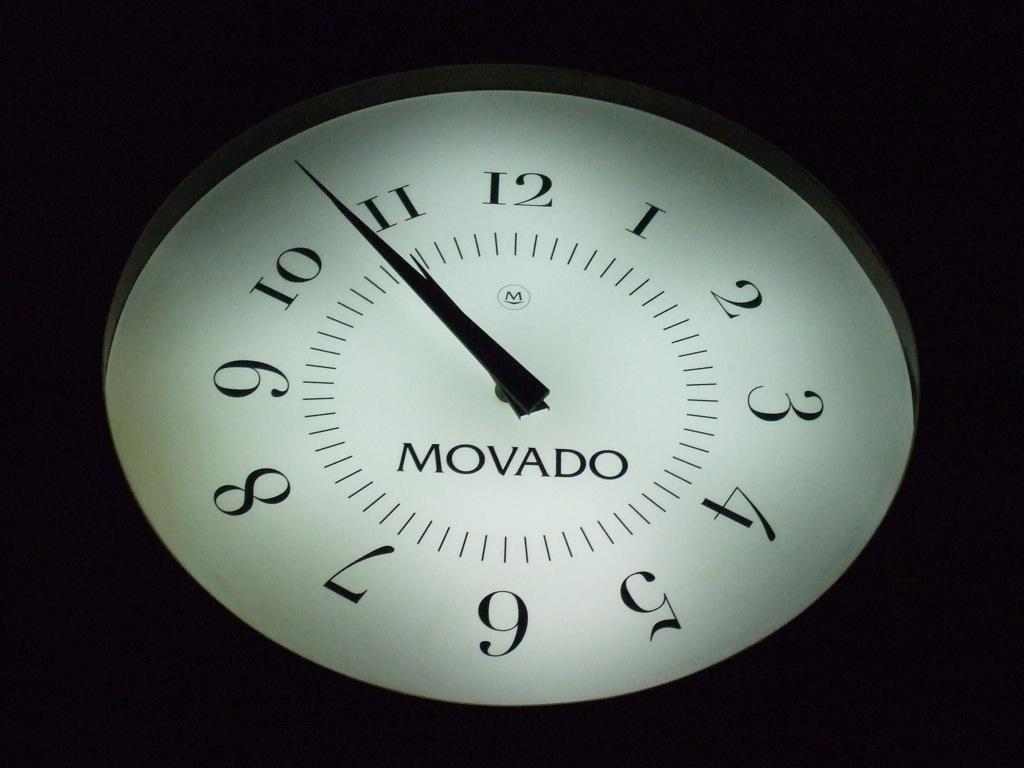<image>
Create a compact narrative representing the image presented. A clock which bears the word Movado and one hand coming up to 11. 